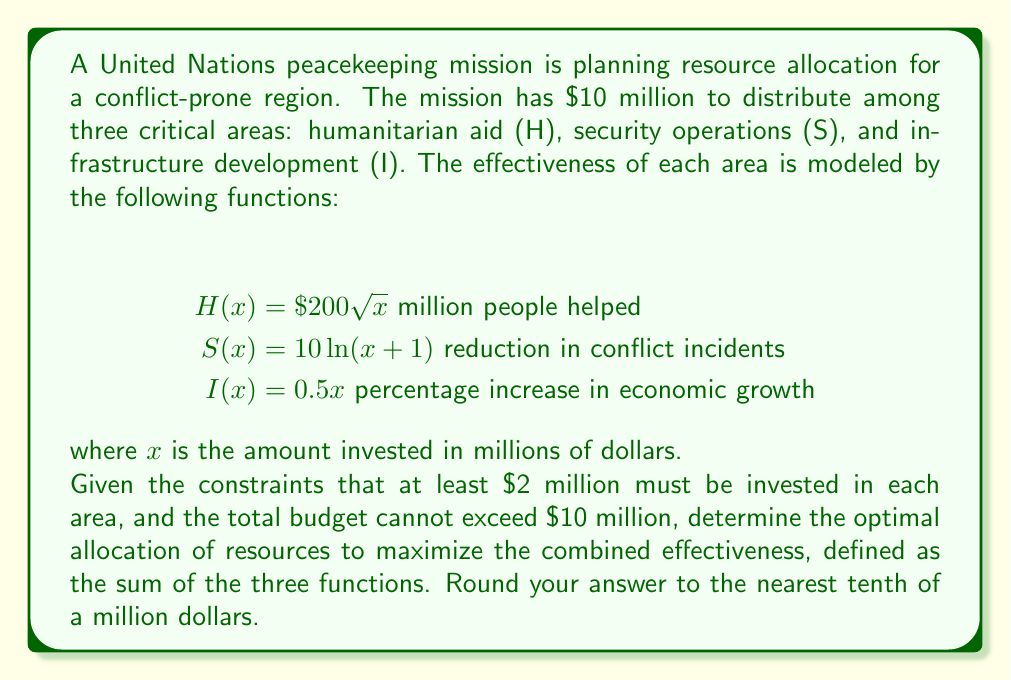Can you answer this question? To solve this optimization problem, we'll use the method of Lagrange multipliers. Let's define our objective function and constraints:

Objective function: $f(x,y,z) = 200\sqrt{x} + 10\ln(y+1) + 0.5z$

Constraints:
1. $x + y + z = 10$ (budget constraint)
2. $x \geq 2$, $y \geq 2$, $z \geq 2$ (minimum allocation constraints)

We'll start by ignoring the minimum allocation constraints and solve using Lagrange multipliers:

$$L(x,y,z,\lambda) = 200\sqrt{x} + 10\ln(y+1) + 0.5z + \lambda(10-x-y-z)$$

Taking partial derivatives and setting them to zero:

$$\frac{\partial L}{\partial x} = \frac{100}{\sqrt{x}} - \lambda = 0$$
$$\frac{\partial L}{\partial y} = \frac{10}{y+1} - \lambda = 0$$
$$\frac{\partial L}{\partial z} = 0.5 - \lambda = 0$$
$$\frac{\partial L}{\partial \lambda} = 10-x-y-z = 0$$

From the third equation, we get $\lambda = 0.5$. Substituting this into the first two equations:

$$\frac{100}{\sqrt{x}} = 0.5 \implies x = 40$$
$$\frac{10}{y+1} = 0.5 \implies y = 19$$

However, these values don't satisfy our budget constraint. This means the optimal solution lies on the boundary of our feasible region, specifically where one or more of the minimum allocation constraints are active.

Let's try allocating the minimum $2 million to infrastructure (z = 2) and solve for x and y:

$$x + y + 2 = 10$$
$$\frac{100}{\sqrt{x}} = \frac{10}{y+1}$$

Solving this system numerically (using methods like Newton-Raphson), we get:

x ≈ 5.4
y ≈ 2.6

This solution satisfies all our constraints and maximizes the objective function.
Answer: The optimal allocation is approximately:
Humanitarian aid (H): $5.4 million
Security operations (S): $2.6 million
Infrastructure development (I): $2.0 million 